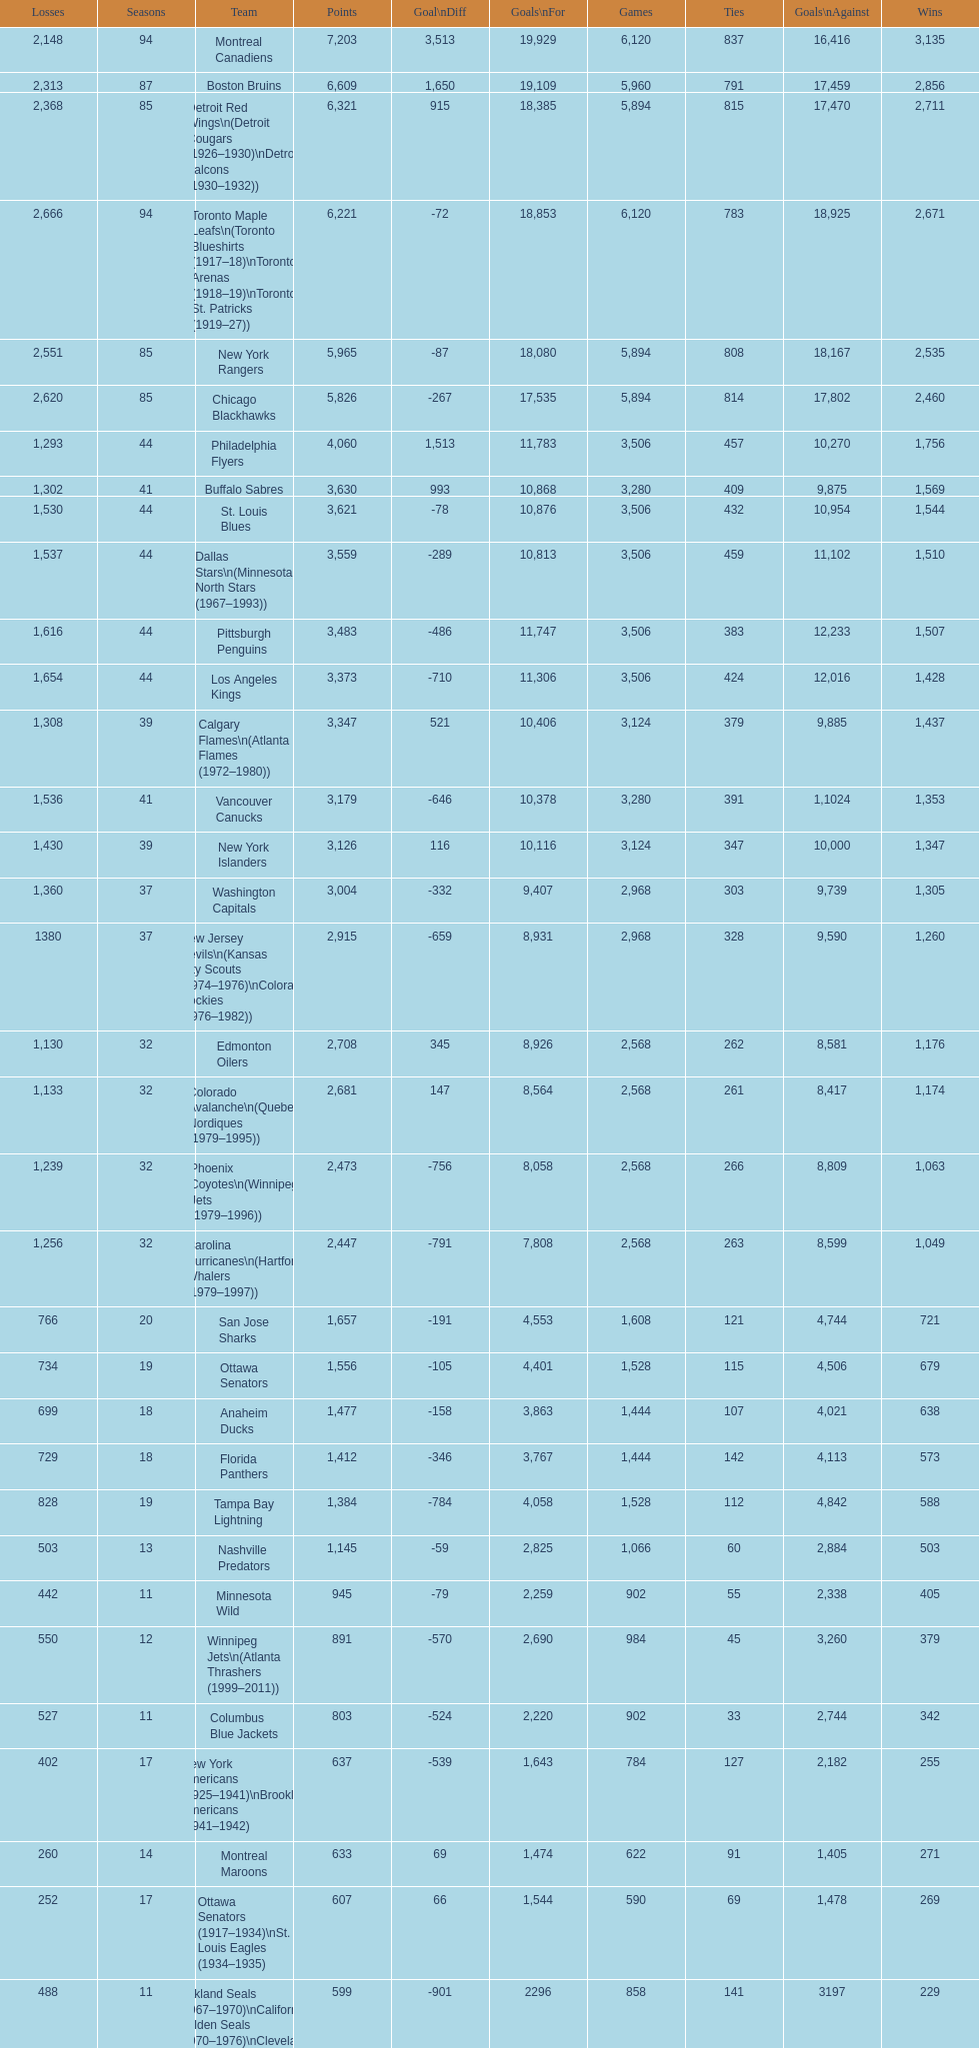Which team was last in terms of points up until this point? Montreal Wanderers. 